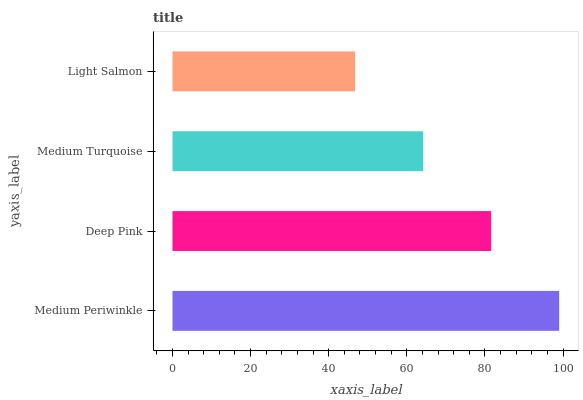Is Light Salmon the minimum?
Answer yes or no. Yes. Is Medium Periwinkle the maximum?
Answer yes or no. Yes. Is Deep Pink the minimum?
Answer yes or no. No. Is Deep Pink the maximum?
Answer yes or no. No. Is Medium Periwinkle greater than Deep Pink?
Answer yes or no. Yes. Is Deep Pink less than Medium Periwinkle?
Answer yes or no. Yes. Is Deep Pink greater than Medium Periwinkle?
Answer yes or no. No. Is Medium Periwinkle less than Deep Pink?
Answer yes or no. No. Is Deep Pink the high median?
Answer yes or no. Yes. Is Medium Turquoise the low median?
Answer yes or no. Yes. Is Light Salmon the high median?
Answer yes or no. No. Is Light Salmon the low median?
Answer yes or no. No. 